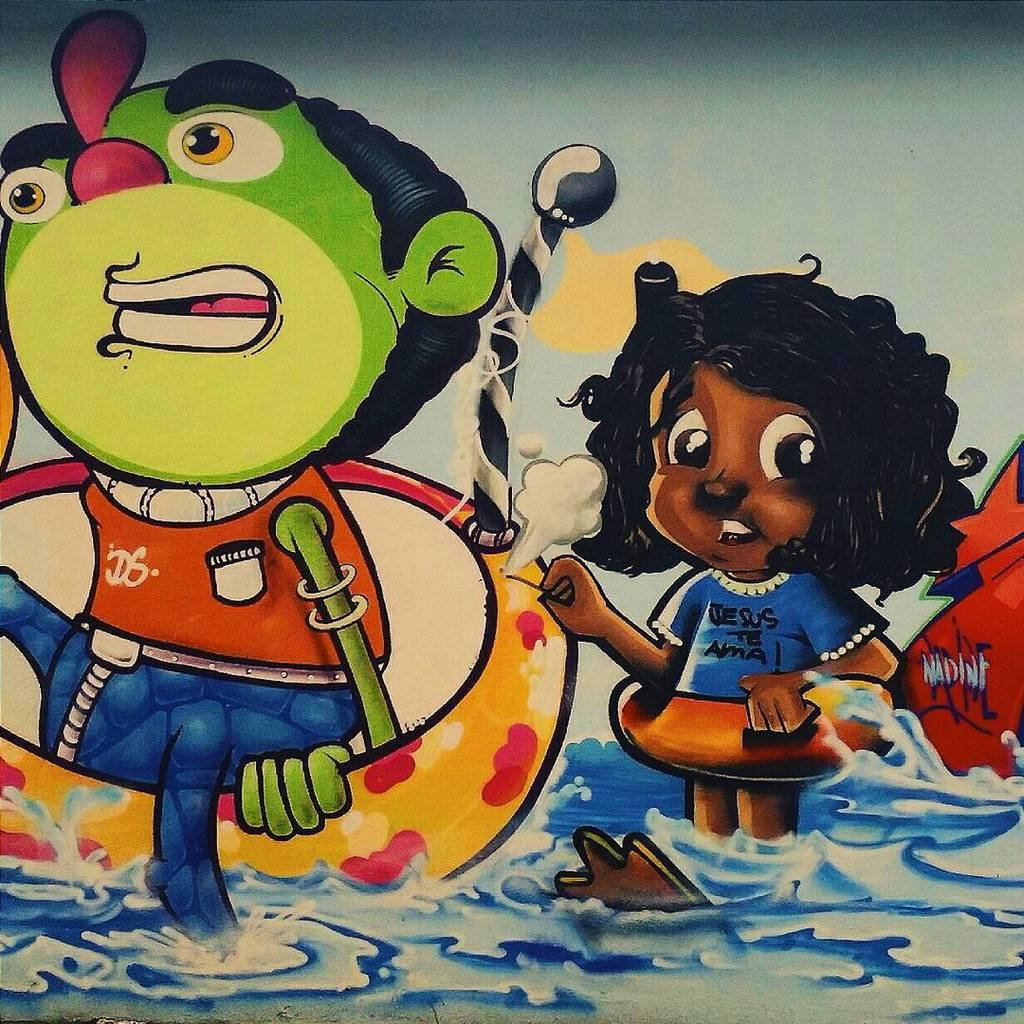What is the main subject of the image? The main subject of the image is a painting. What type of images are depicted in the painting? The painting contains cartoon images. What type of joke is being told by the cartoon character in the painting? There is no indication of a joke being told in the painting, as it only contains cartoon images. How does the ray of light affect the painting in the image? There is no ray of light present in the image; it only features a painting with cartoon images. 